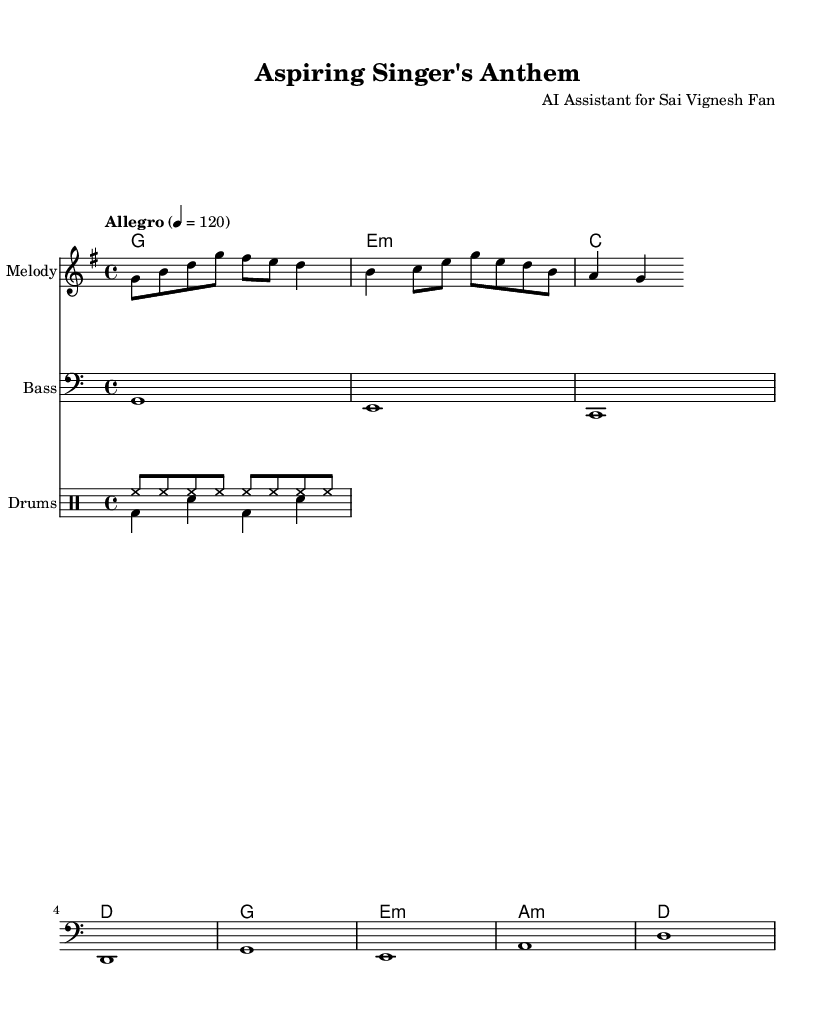What is the key signature of this music? The key signature is indicated at the beginning of the staff, which shows one sharp. This corresponds to the G major scale.
Answer: G major What is the time signature of this music? The time signature is found at the beginning of the score, showing four beats per measure, so it is notated as 4/4.
Answer: 4/4 What is the tempo marking of this music? The tempo marking indicates the speed of the piece and is written above the staff. It shows that the tempo is "Allegro" at a rate of 120 beats per minute.
Answer: Allegro 120 How many measures are there in the melody? By counting the distinct measure bars in the melody staff, we can determine the total. There are 2 sets of measures composed of 4 beats each, equating to a total of 2 measures.
Answer: 2 What type of accompaniment is used in this music? The accompaniment shows chords below the melody in the chord mode. In this case, the arrangement employs a mix of major and minor chords to create harmony with the melody.
Answer: Chord accompaniment Which percussion elements are prominently used in this rap? The drum section includes a hihat pattern and a bass drum with a snare drum, which are common in rap music to establish a driving beat and rhythm, specifically indicated in the drum staff.
Answer: Hihat and bass drum What does the lyric theme of the song suggest? The lyrics indicate a narrative journey of ambition and striving for success, aligned with the supportive and motivational aspects found in upbeat rap, which are emphasized through the lyrical phrasing.
Answer: Ambition and success 